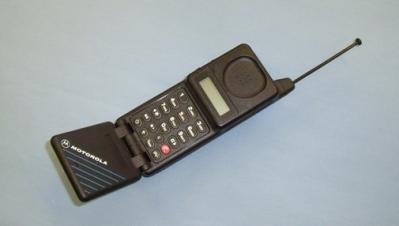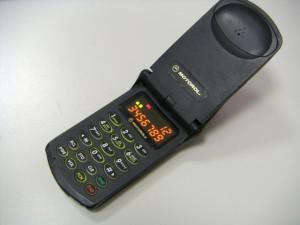The first image is the image on the left, the second image is the image on the right. Evaluate the accuracy of this statement regarding the images: "Both phones are pointing to the right.". Is it true? Answer yes or no. Yes. 